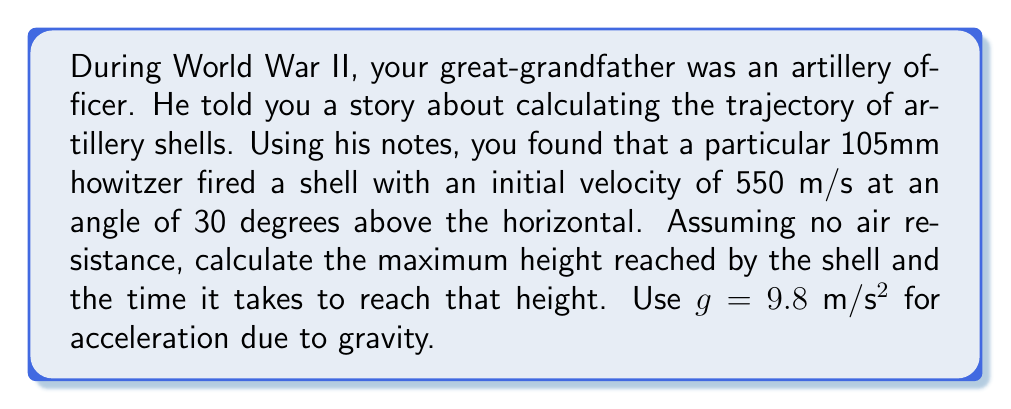Could you help me with this problem? To solve this problem, we'll use the quadratic function that describes the trajectory of a projectile and the equations of motion for projectile motion.

1. First, let's break down the initial velocity into its vertical and horizontal components:
   $v_{0x} = v_0 \cos \theta = 550 \cos 30° = 476.31$ m/s
   $v_{0y} = v_0 \sin \theta = 550 \sin 30° = 275$ m/s

2. The maximum height is reached when the vertical velocity becomes zero. We can use the equation:
   $v_y = v_{0y} - gt$
   
   At the highest point, $v_y = 0$, so:
   $0 = 275 - 9.8t$
   $t = \frac{275}{9.8} = 28.06$ seconds

3. This is the time it takes to reach the maximum height. To find the maximum height, we can use the equation:
   $y = v_{0y}t - \frac{1}{2}gt^2$
   
   Substituting our values:
   $y = 275(28.06) - \frac{1}{2}(9.8)(28.06)^2$
   $y = 7716.5 - 3853.25 = 3863.25$ meters

Therefore, the maximum height reached by the shell is approximately 3863.25 meters, and it takes about 28.06 seconds to reach this height.
Answer: Maximum height: 3863.25 meters
Time to reach maximum height: 28.06 seconds 